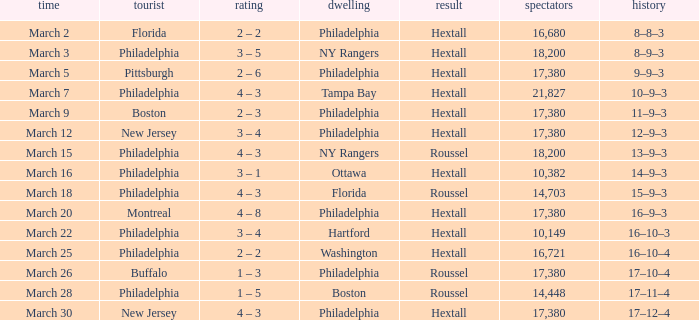Date of march 30 involves what home? Philadelphia. 